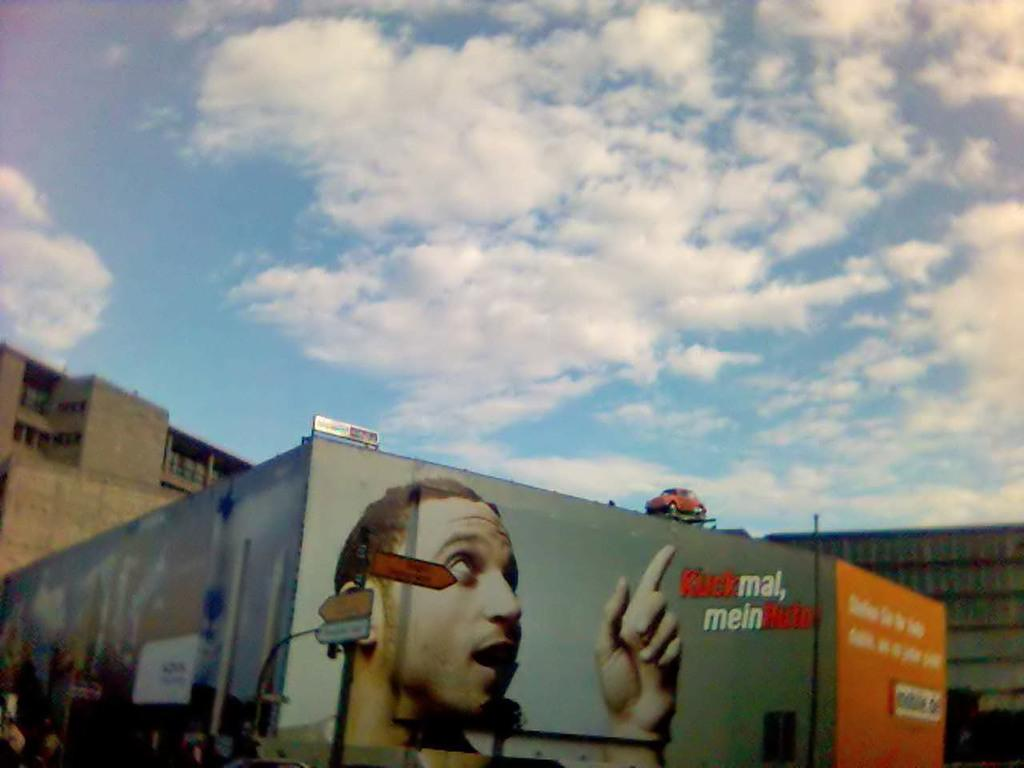What type of structures can be seen in the image? There are buildings in the image. What is attached to the wall in the image? There is a poster in the image, which contains text and a picture of a man. What object related to transportation is present in the image? There is a toy vehicle in the image. What is the surface on which the poster is attached? There is a board in the image. What is the tall, vertical object in the image? There is a pole in the image. What is the condition of the sky in the image? The sky is visible in the image and appears to be cloudy. What type of canvas is being used for arithmetic in the image? There is no canvas or arithmetic activity present in the image. What type of organization is responsible for the poster in the image? The image does not provide information about the organization responsible for the poster. 